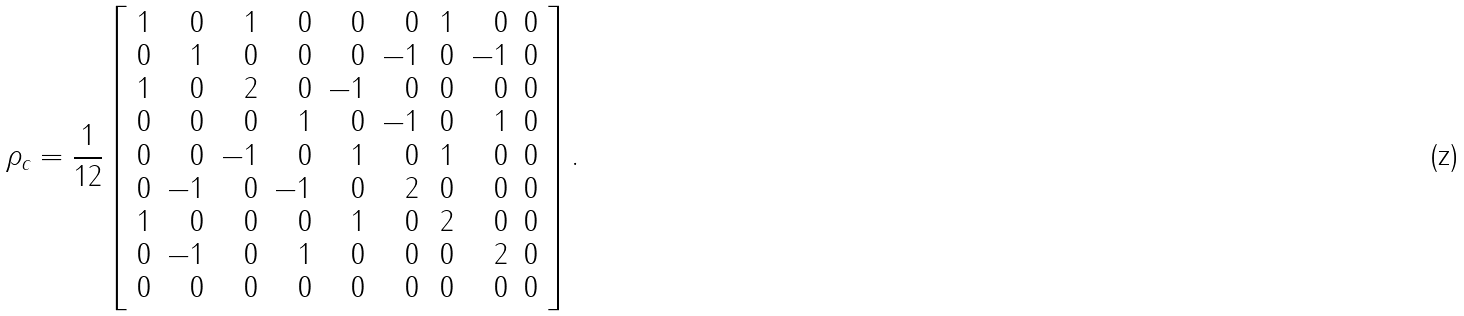<formula> <loc_0><loc_0><loc_500><loc_500>\rho _ { c } = \frac { 1 } { 1 2 } \left [ \begin{array} { r r r r r r r r r } 1 & 0 & 1 & 0 & 0 & 0 & \, 1 & 0 & 0 \\ 0 & 1 & 0 & 0 & 0 & - 1 & 0 & - 1 & 0 \\ 1 & 0 & 2 & 0 & - 1 & 0 & 0 & 0 & 0 \\ 0 & 0 & 0 & 1 & 0 & - 1 & 0 & 1 & 0 \\ 0 & 0 & - 1 & 0 & 1 & 0 & 1 & 0 & 0 \\ 0 & - 1 & 0 & - 1 & 0 & 2 & 0 & 0 & 0 \\ 1 & 0 & 0 & 0 & 1 & 0 & 2 & 0 & 0 \\ 0 & - 1 & 0 & 1 & 0 & 0 & 0 & 2 & 0 \\ 0 & 0 & 0 & 0 & 0 & 0 & 0 & 0 & 0 \end{array} \right ] .</formula> 